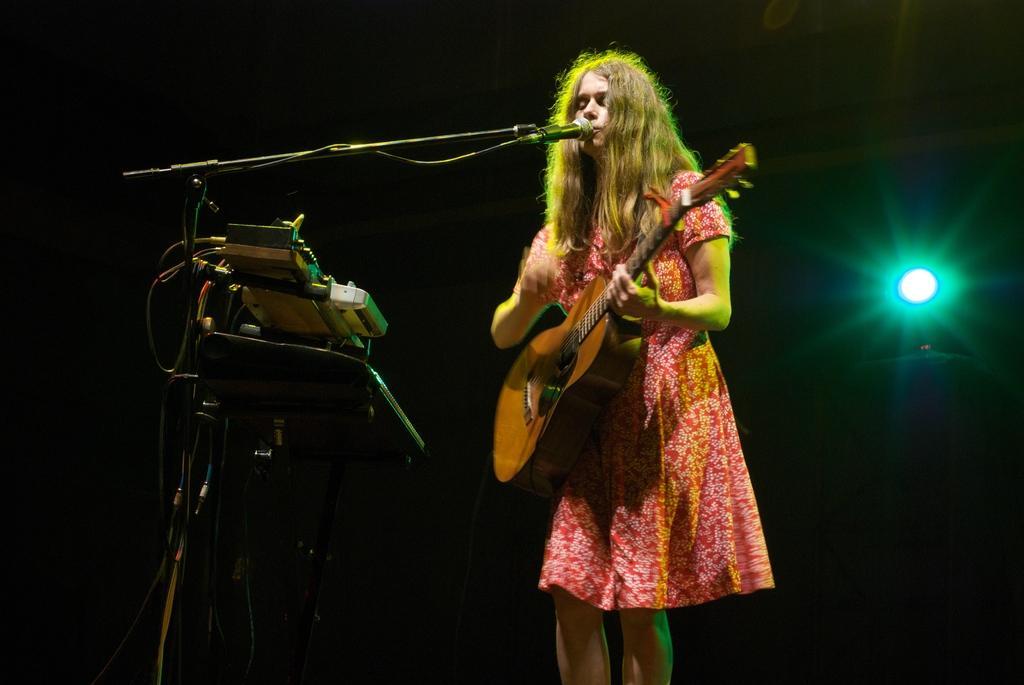Describe this image in one or two sentences. In this image, in the middle there is a girl she is standing and holding a music instrument which is n yellow color, she is singing in the microphone which is in black color, in the left side there is a stand which is in black color, in the right side there is a light which is in green color. 